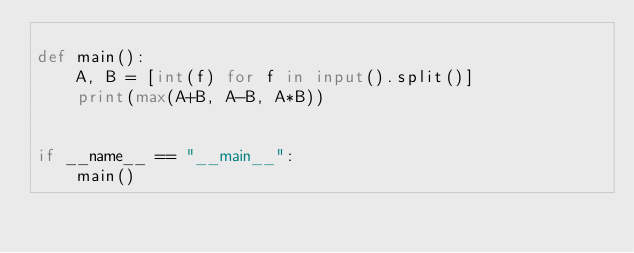Convert code to text. <code><loc_0><loc_0><loc_500><loc_500><_Python_>
def main():
    A, B = [int(f) for f in input().split()]
    print(max(A+B, A-B, A*B))


if __name__ == "__main__":
    main()</code> 